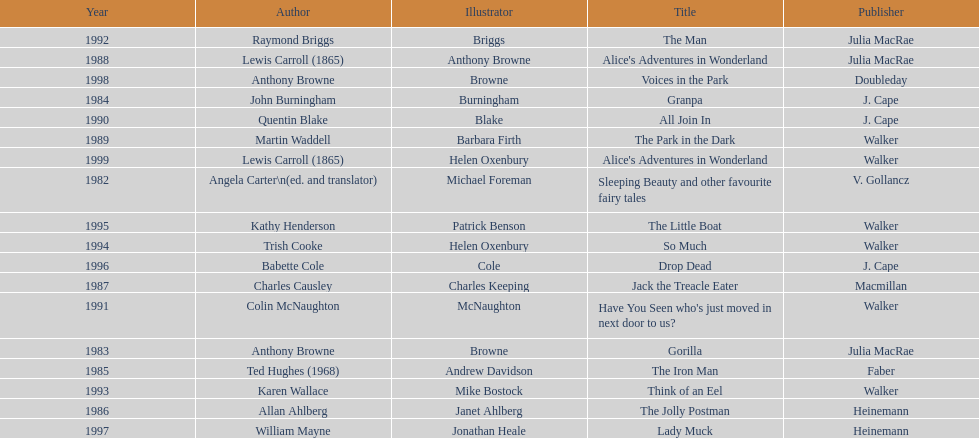Which illustrator was responsible for the last award winner? Helen Oxenbury. 